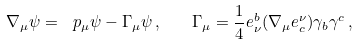<formula> <loc_0><loc_0><loc_500><loc_500>\nabla _ { \mu } \psi = \ p _ { \mu } \psi - \Gamma _ { \mu } \psi \, , \quad \Gamma _ { \mu } = \frac { 1 } { 4 } e _ { \nu } ^ { b } ( \nabla _ { \mu } e ^ { \nu } _ { c } ) \gamma _ { b } \gamma ^ { c } \, ,</formula> 